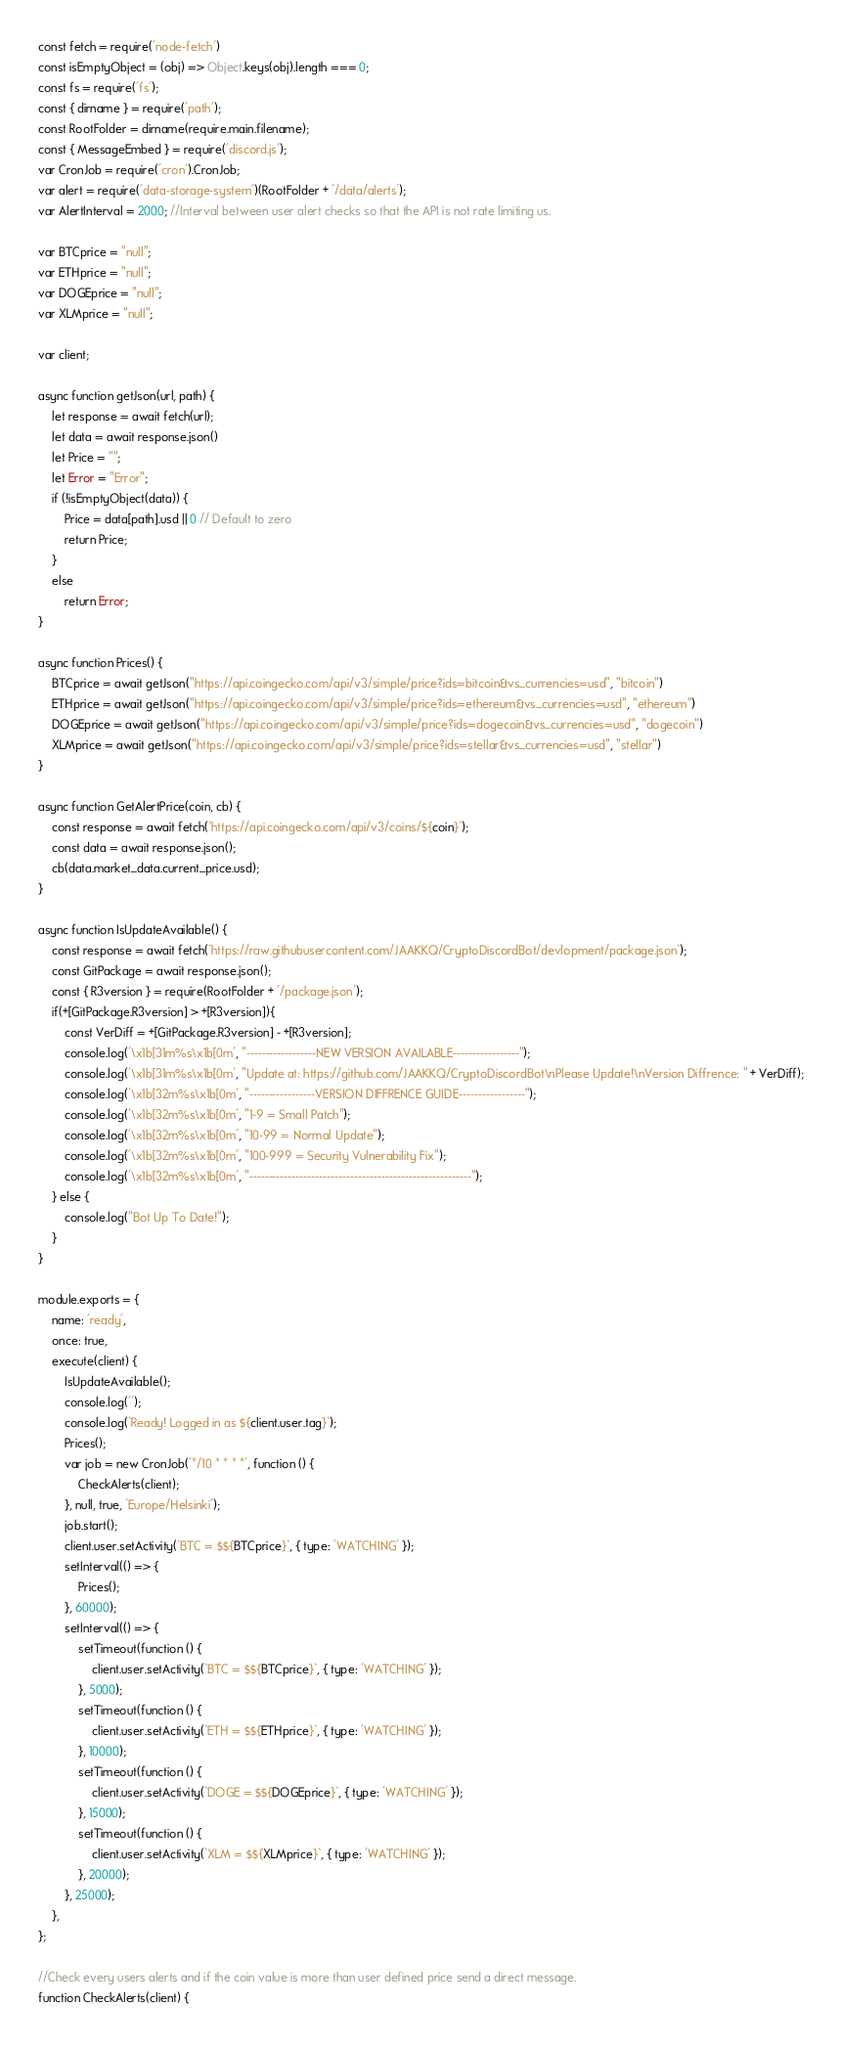<code> <loc_0><loc_0><loc_500><loc_500><_JavaScript_>const fetch = require('node-fetch')
const isEmptyObject = (obj) => Object.keys(obj).length === 0;
const fs = require('fs');
const { dirname } = require('path');
const RootFolder = dirname(require.main.filename);
const { MessageEmbed } = require('discord.js');
var CronJob = require('cron').CronJob;
var alert = require('data-storage-system')(RootFolder + '/data/alerts');
var AlertInterval = 2000; //Interval between user alert checks so that the API is not rate limiting us.

var BTCprice = "null";
var ETHprice = "null";
var DOGEprice = "null";
var XLMprice = "null";

var client;

async function getJson(url, path) {
	let response = await fetch(url);
	let data = await response.json()
	let Price = "";
	let Error = "Error";
	if (!isEmptyObject(data)) {
		Price = data[path].usd || 0 // Default to zero
		return Price;
	}
	else
		return Error;
}

async function Prices() {
	BTCprice = await getJson("https://api.coingecko.com/api/v3/simple/price?ids=bitcoin&vs_currencies=usd", "bitcoin")
	ETHprice = await getJson("https://api.coingecko.com/api/v3/simple/price?ids=ethereum&vs_currencies=usd", "ethereum")
	DOGEprice = await getJson("https://api.coingecko.com/api/v3/simple/price?ids=dogecoin&vs_currencies=usd", "dogecoin")
	XLMprice = await getJson("https://api.coingecko.com/api/v3/simple/price?ids=stellar&vs_currencies=usd", "stellar")
}

async function GetAlertPrice(coin, cb) {
	const response = await fetch(`https://api.coingecko.com/api/v3/coins/${coin}`);
	const data = await response.json();
	cb(data.market_data.current_price.usd);
} 

async function IsUpdateAvailable() {
	const response = await fetch(`https://raw.githubusercontent.com/JAAKKQ/CryptoDiscordBot/devlopment/package.json`);
	const GitPackage = await response.json();
	const { R3version } = require(RootFolder + '/package.json');
	if(+[GitPackage.R3version] > +[R3version]){
		const VerDiff = +[GitPackage.R3version] - +[R3version];
		console.log('\x1b[31m%s\x1b[0m', "------------------NEW VERSION AVAILABLE-----------------");
		console.log('\x1b[31m%s\x1b[0m', "Update at: https://github.com/JAAKKQ/CryptoDiscordBot\nPlease Update!\nVersion Diffrence: " + VerDiff);
		console.log('\x1b[32m%s\x1b[0m', "-----------------VERSION DIFFRENCE GUIDE-----------------");
		console.log('\x1b[32m%s\x1b[0m', "1-9 = Small Patch");
		console.log('\x1b[32m%s\x1b[0m', "10-99 = Normal Update");
		console.log('\x1b[32m%s\x1b[0m', "100-999 = Security Vulnerability Fix");
		console.log('\x1b[32m%s\x1b[0m', "---------------------------------------------------------");
	} else {
		console.log("Bot Up To Date!");
	}
}

module.exports = {
	name: 'ready',
	once: true,
	execute(client) {
		IsUpdateAvailable();
		console.log('');
		console.log(`Ready! Logged in as ${client.user.tag}`);
		Prices();
		var job = new CronJob('*/10 * * * *', function () {
			CheckAlerts(client);
		}, null, true, 'Europe/Helsinki');
		job.start();
		client.user.setActivity(`BTC = $${BTCprice}`, { type: 'WATCHING' });
		setInterval(() => {
			Prices();
		}, 60000);
		setInterval(() => {
			setTimeout(function () {
				client.user.setActivity(`BTC = $${BTCprice}`, { type: 'WATCHING' });
			}, 5000);
			setTimeout(function () {
				client.user.setActivity(`ETH = $${ETHprice}`, { type: 'WATCHING' });
			}, 10000);
			setTimeout(function () {
				client.user.setActivity(`DOGE = $${DOGEprice}`, { type: 'WATCHING' });
			}, 15000);
			setTimeout(function () {
				client.user.setActivity(`XLM = $${XLMprice}`, { type: 'WATCHING' });
			}, 20000);
		}, 25000);
	},
};

//Check every users alerts and if the coin value is more than user defined price send a direct message.
function CheckAlerts(client) {</code> 